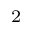<formula> <loc_0><loc_0><loc_500><loc_500>^ { 2 }</formula> 